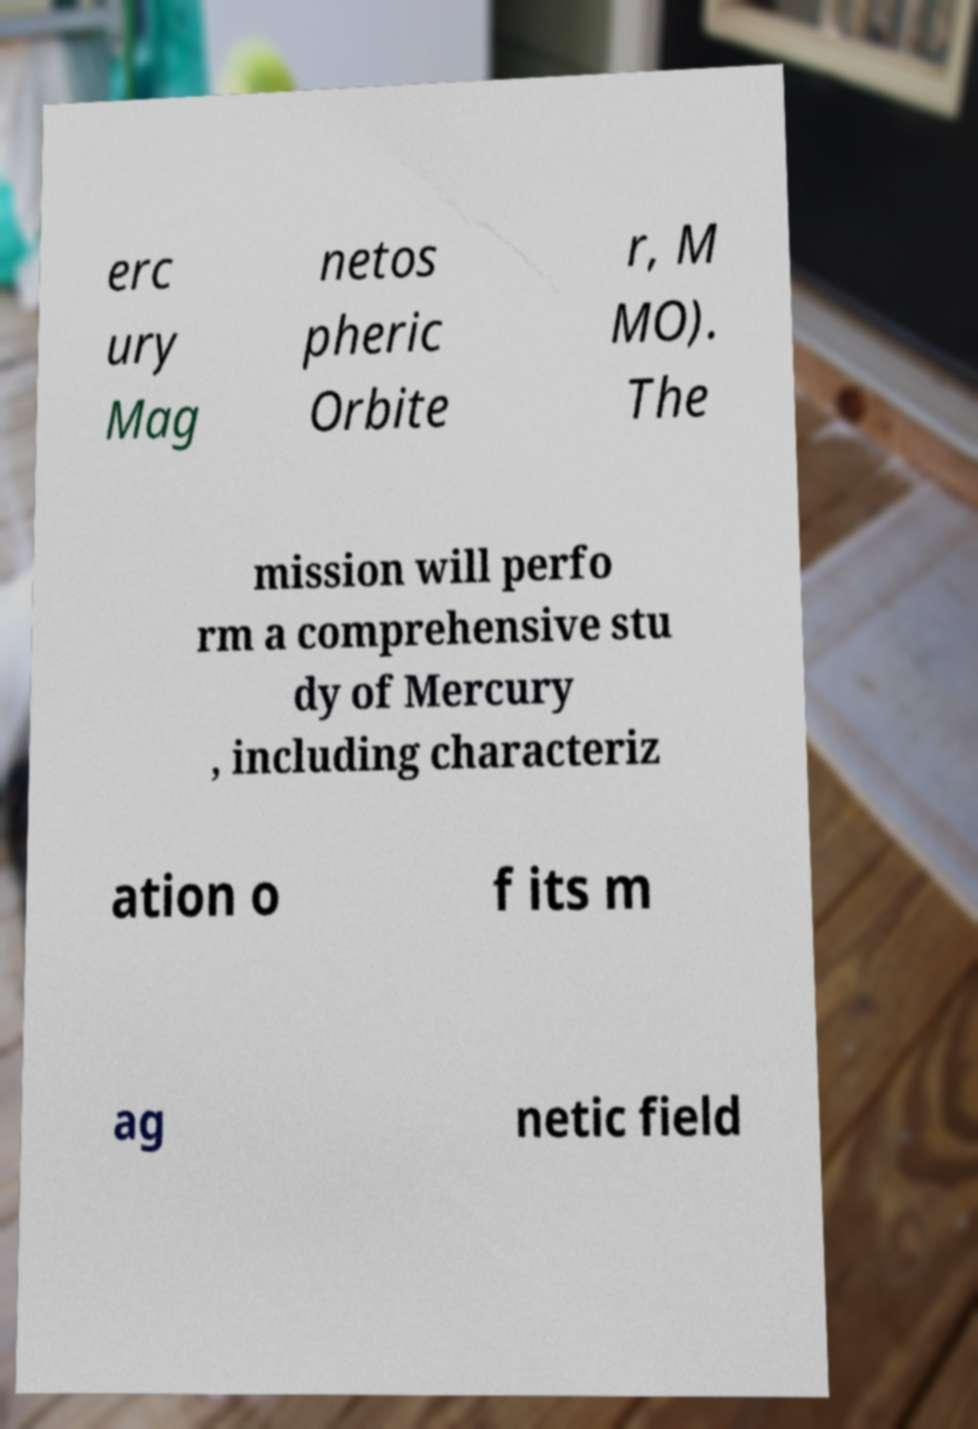Could you assist in decoding the text presented in this image and type it out clearly? erc ury Mag netos pheric Orbite r, M MO). The mission will perfo rm a comprehensive stu dy of Mercury , including characteriz ation o f its m ag netic field 